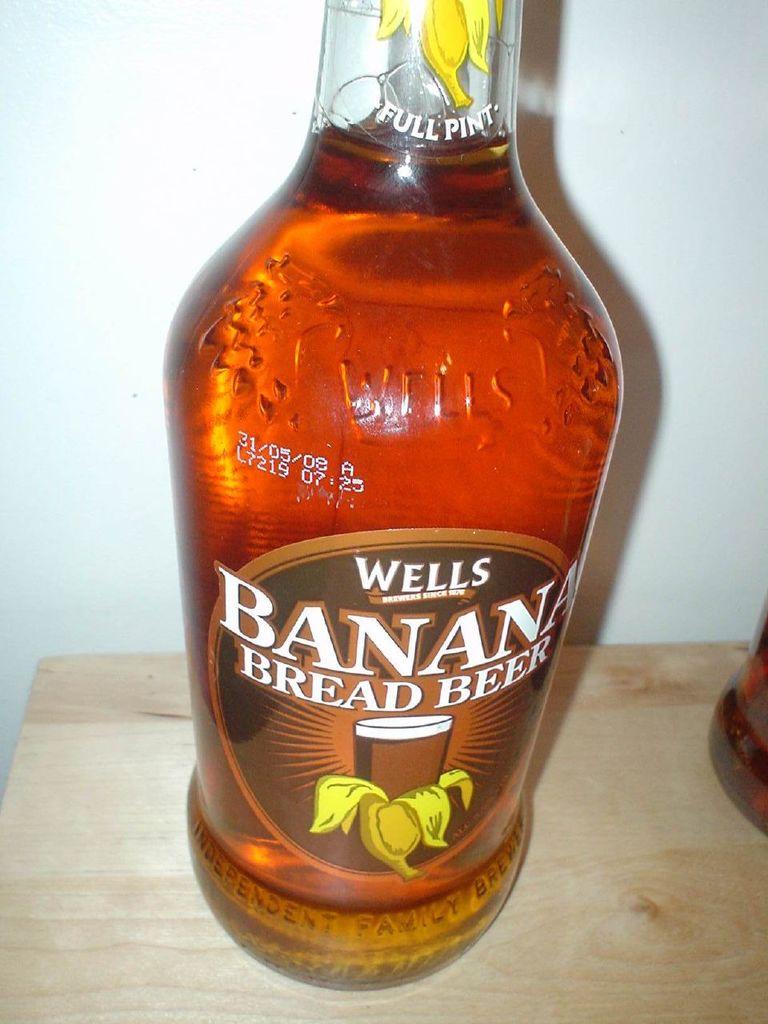When does this beer expire?
Provide a short and direct response. 31/05/08. 